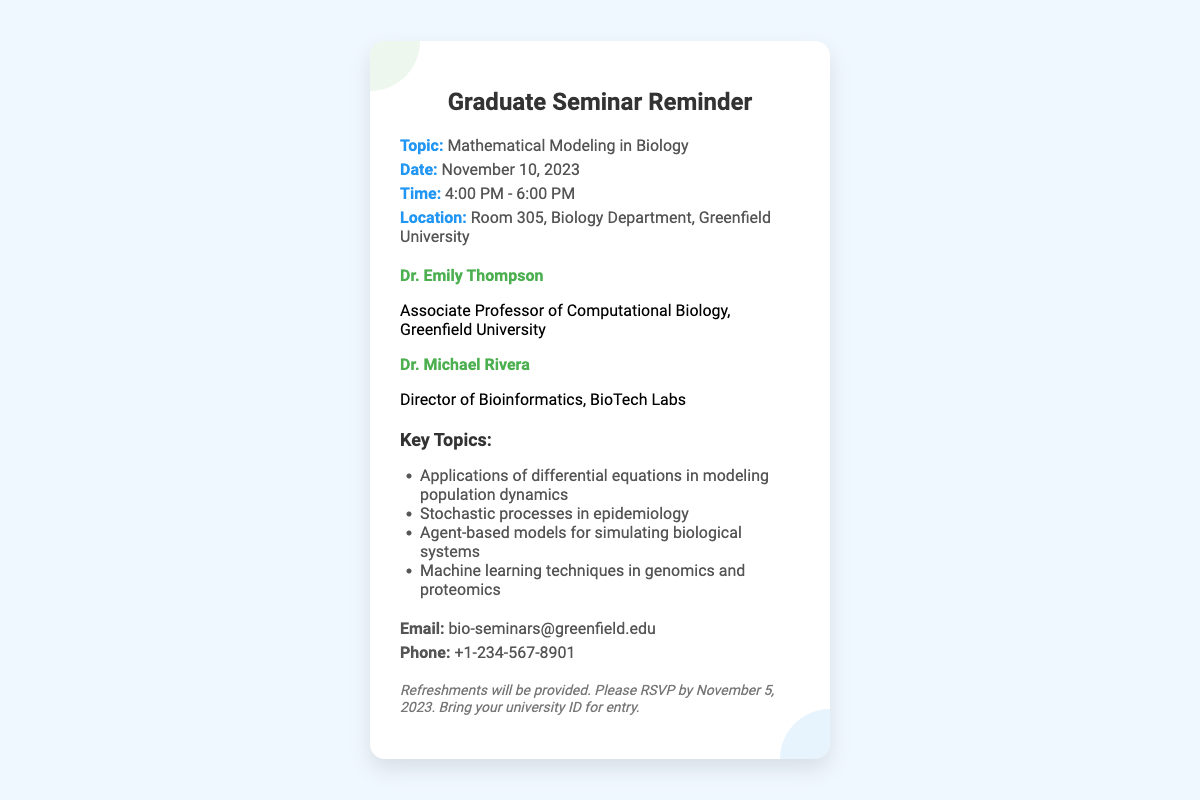What is the topic of the seminar? The topic is specified in the seminar details section of the document.
Answer: Mathematical Modeling in Biology When is the seminar scheduled? The date is clearly indicated in the seminar details section.
Answer: November 10, 2023 What time does the seminar start? The starting time is provided in the seminar details section.
Answer: 4:00 PM Who is one of the speakers? The names of the speakers are listed in the speakers section of the document.
Answer: Dr. Emily Thompson What is the location of the seminar? The location is mentioned in the seminar details section.
Answer: Room 305, Biology Department, Greenfield University What is one key topic discussed at the seminar? The key topics are detailed in the key topics section of the document.
Answer: Applications of differential equations in modeling population dynamics What should attendees bring for entry? This information is noted in the additional notes section.
Answer: University ID What is the RSVP deadline for the seminar? The RSVP date is provided in the additional notes section of the document.
Answer: November 5, 2023 What type of refreshments will be provided? This detail is mentioned in the additional notes section.
Answer: Refreshments will be provided 